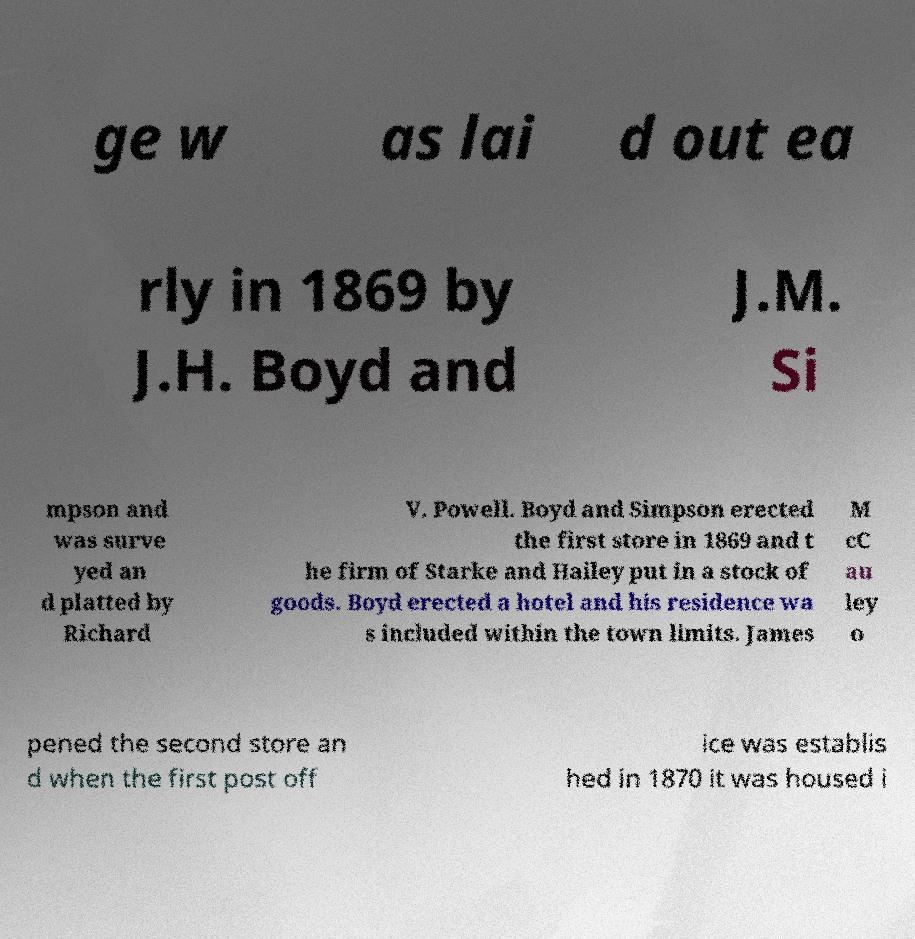Please read and relay the text visible in this image. What does it say? ge w as lai d out ea rly in 1869 by J.H. Boyd and J.M. Si mpson and was surve yed an d platted by Richard V. Powell. Boyd and Simpson erected the first store in 1869 and t he firm of Starke and Hailey put in a stock of goods. Boyd erected a hotel and his residence wa s included within the town limits. James M cC au ley o pened the second store an d when the first post off ice was establis hed in 1870 it was housed i 